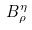<formula> <loc_0><loc_0><loc_500><loc_500>B _ { \rho } ^ { \eta }</formula> 